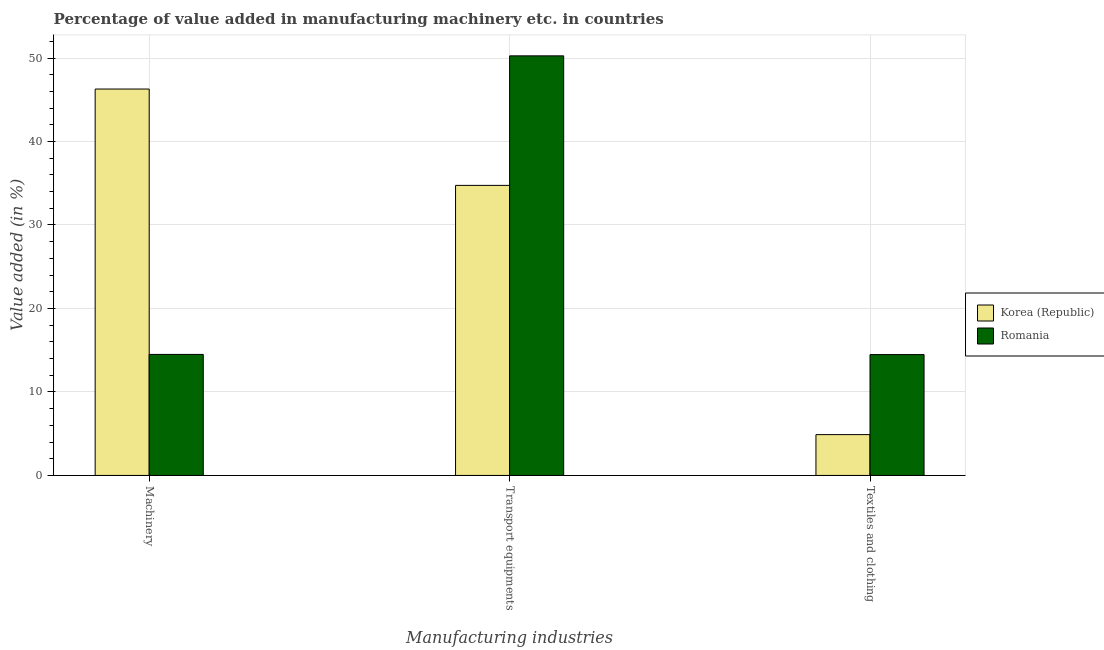How many groups of bars are there?
Offer a terse response. 3. Are the number of bars on each tick of the X-axis equal?
Your answer should be very brief. Yes. How many bars are there on the 1st tick from the left?
Offer a very short reply. 2. How many bars are there on the 2nd tick from the right?
Provide a succinct answer. 2. What is the label of the 1st group of bars from the left?
Provide a short and direct response. Machinery. What is the value added in manufacturing textile and clothing in Romania?
Your response must be concise. 14.48. Across all countries, what is the maximum value added in manufacturing machinery?
Provide a short and direct response. 46.29. Across all countries, what is the minimum value added in manufacturing machinery?
Provide a short and direct response. 14.5. In which country was the value added in manufacturing machinery minimum?
Your answer should be very brief. Romania. What is the total value added in manufacturing machinery in the graph?
Offer a terse response. 60.78. What is the difference between the value added in manufacturing transport equipments in Romania and that in Korea (Republic)?
Make the answer very short. 15.52. What is the difference between the value added in manufacturing machinery in Romania and the value added in manufacturing textile and clothing in Korea (Republic)?
Make the answer very short. 9.61. What is the average value added in manufacturing machinery per country?
Your answer should be compact. 30.39. What is the difference between the value added in manufacturing machinery and value added in manufacturing textile and clothing in Romania?
Your answer should be very brief. 0.02. What is the ratio of the value added in manufacturing machinery in Romania to that in Korea (Republic)?
Provide a short and direct response. 0.31. Is the difference between the value added in manufacturing machinery in Romania and Korea (Republic) greater than the difference between the value added in manufacturing textile and clothing in Romania and Korea (Republic)?
Ensure brevity in your answer.  No. What is the difference between the highest and the second highest value added in manufacturing transport equipments?
Keep it short and to the point. 15.52. What is the difference between the highest and the lowest value added in manufacturing machinery?
Your response must be concise. 31.79. In how many countries, is the value added in manufacturing transport equipments greater than the average value added in manufacturing transport equipments taken over all countries?
Keep it short and to the point. 1. Is the sum of the value added in manufacturing textile and clothing in Korea (Republic) and Romania greater than the maximum value added in manufacturing transport equipments across all countries?
Offer a very short reply. No. What does the 1st bar from the left in Transport equipments represents?
Your response must be concise. Korea (Republic). What does the 1st bar from the right in Textiles and clothing represents?
Provide a succinct answer. Romania. How many bars are there?
Offer a terse response. 6. Does the graph contain any zero values?
Your answer should be very brief. No. How are the legend labels stacked?
Your answer should be very brief. Vertical. What is the title of the graph?
Provide a short and direct response. Percentage of value added in manufacturing machinery etc. in countries. Does "El Salvador" appear as one of the legend labels in the graph?
Offer a terse response. No. What is the label or title of the X-axis?
Provide a short and direct response. Manufacturing industries. What is the label or title of the Y-axis?
Your response must be concise. Value added (in %). What is the Value added (in %) in Korea (Republic) in Machinery?
Keep it short and to the point. 46.29. What is the Value added (in %) of Romania in Machinery?
Make the answer very short. 14.5. What is the Value added (in %) of Korea (Republic) in Transport equipments?
Offer a terse response. 34.74. What is the Value added (in %) of Romania in Transport equipments?
Make the answer very short. 50.26. What is the Value added (in %) in Korea (Republic) in Textiles and clothing?
Ensure brevity in your answer.  4.89. What is the Value added (in %) in Romania in Textiles and clothing?
Provide a short and direct response. 14.48. Across all Manufacturing industries, what is the maximum Value added (in %) in Korea (Republic)?
Offer a terse response. 46.29. Across all Manufacturing industries, what is the maximum Value added (in %) in Romania?
Ensure brevity in your answer.  50.26. Across all Manufacturing industries, what is the minimum Value added (in %) in Korea (Republic)?
Your answer should be compact. 4.89. Across all Manufacturing industries, what is the minimum Value added (in %) of Romania?
Your answer should be very brief. 14.48. What is the total Value added (in %) in Korea (Republic) in the graph?
Provide a succinct answer. 85.92. What is the total Value added (in %) of Romania in the graph?
Ensure brevity in your answer.  79.23. What is the difference between the Value added (in %) of Korea (Republic) in Machinery and that in Transport equipments?
Provide a short and direct response. 11.54. What is the difference between the Value added (in %) of Romania in Machinery and that in Transport equipments?
Offer a terse response. -35.76. What is the difference between the Value added (in %) of Korea (Republic) in Machinery and that in Textiles and clothing?
Your response must be concise. 41.4. What is the difference between the Value added (in %) of Romania in Machinery and that in Textiles and clothing?
Offer a very short reply. 0.02. What is the difference between the Value added (in %) of Korea (Republic) in Transport equipments and that in Textiles and clothing?
Keep it short and to the point. 29.85. What is the difference between the Value added (in %) in Romania in Transport equipments and that in Textiles and clothing?
Ensure brevity in your answer.  35.78. What is the difference between the Value added (in %) in Korea (Republic) in Machinery and the Value added (in %) in Romania in Transport equipments?
Your answer should be very brief. -3.97. What is the difference between the Value added (in %) in Korea (Republic) in Machinery and the Value added (in %) in Romania in Textiles and clothing?
Provide a succinct answer. 31.81. What is the difference between the Value added (in %) of Korea (Republic) in Transport equipments and the Value added (in %) of Romania in Textiles and clothing?
Give a very brief answer. 20.27. What is the average Value added (in %) in Korea (Republic) per Manufacturing industries?
Give a very brief answer. 28.64. What is the average Value added (in %) of Romania per Manufacturing industries?
Your answer should be very brief. 26.41. What is the difference between the Value added (in %) in Korea (Republic) and Value added (in %) in Romania in Machinery?
Provide a succinct answer. 31.79. What is the difference between the Value added (in %) of Korea (Republic) and Value added (in %) of Romania in Transport equipments?
Make the answer very short. -15.52. What is the difference between the Value added (in %) of Korea (Republic) and Value added (in %) of Romania in Textiles and clothing?
Provide a succinct answer. -9.59. What is the ratio of the Value added (in %) of Korea (Republic) in Machinery to that in Transport equipments?
Offer a terse response. 1.33. What is the ratio of the Value added (in %) of Romania in Machinery to that in Transport equipments?
Give a very brief answer. 0.29. What is the ratio of the Value added (in %) of Korea (Republic) in Machinery to that in Textiles and clothing?
Your answer should be compact. 9.47. What is the ratio of the Value added (in %) of Korea (Republic) in Transport equipments to that in Textiles and clothing?
Ensure brevity in your answer.  7.11. What is the ratio of the Value added (in %) of Romania in Transport equipments to that in Textiles and clothing?
Offer a very short reply. 3.47. What is the difference between the highest and the second highest Value added (in %) of Korea (Republic)?
Give a very brief answer. 11.54. What is the difference between the highest and the second highest Value added (in %) of Romania?
Provide a succinct answer. 35.76. What is the difference between the highest and the lowest Value added (in %) in Korea (Republic)?
Keep it short and to the point. 41.4. What is the difference between the highest and the lowest Value added (in %) of Romania?
Keep it short and to the point. 35.78. 